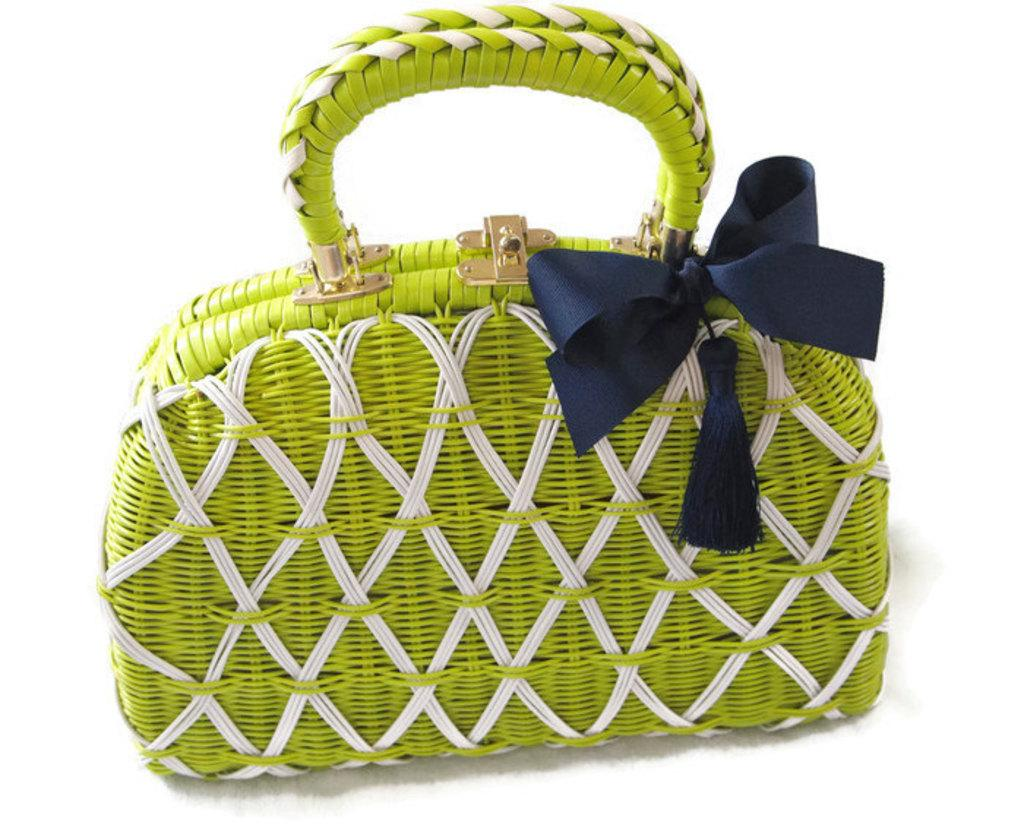What object can be seen in the image? There is a bag in the image. Can you describe the appearance of the bag? The bag is green and white in color, and there is a blue color ribbon tied on it. What type of curtain is hanging in the background of the image? There is no curtain present in the image; it only features a bag with a ribbon. 